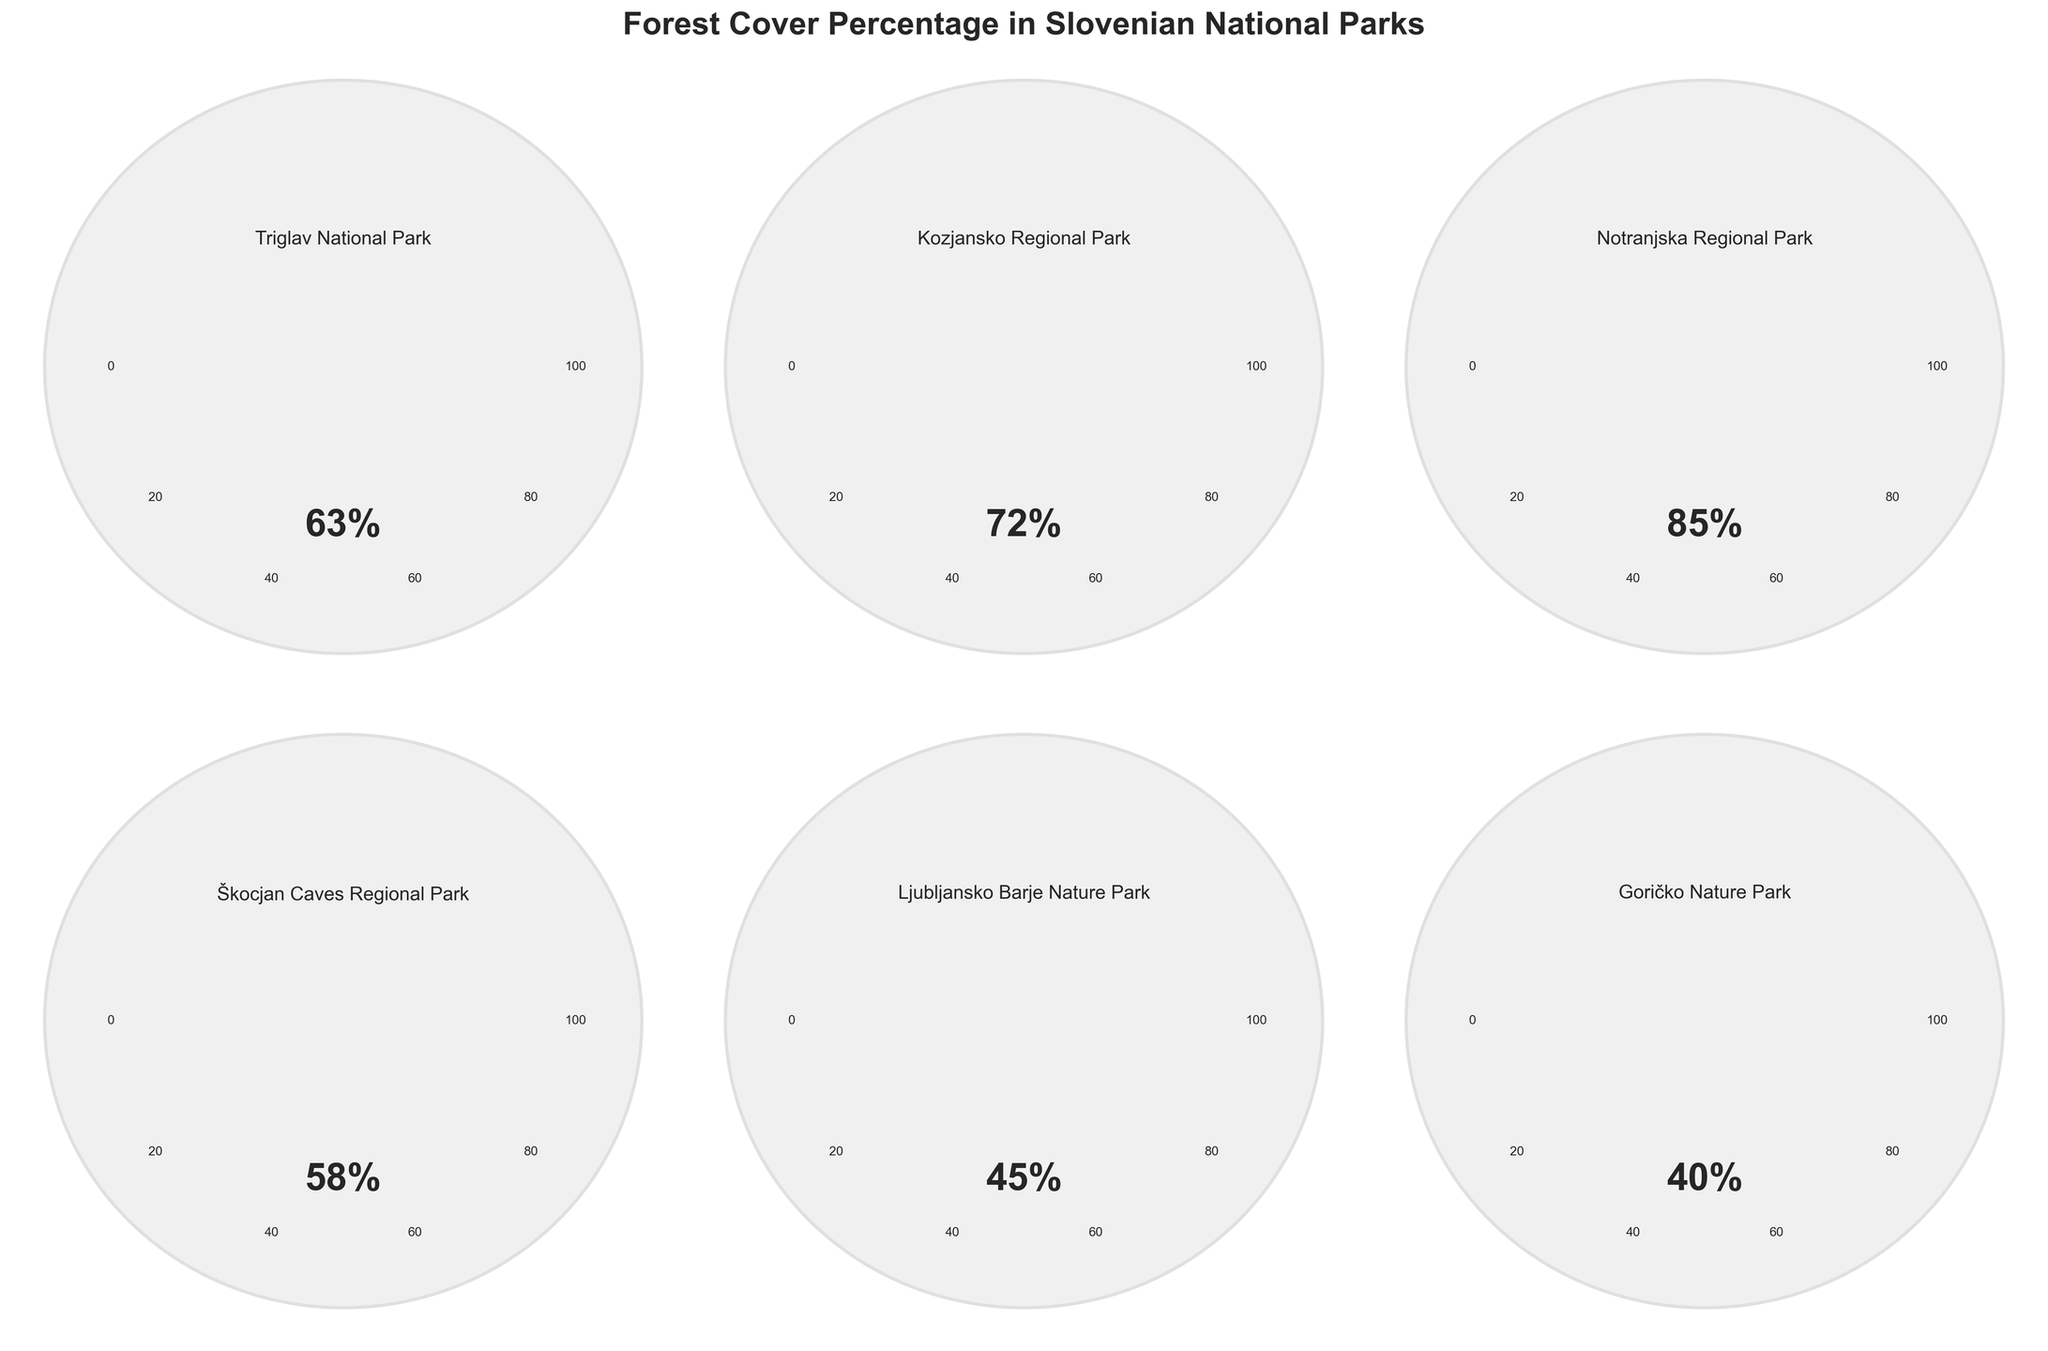What is the title of the figure? The title is typically at the top of the figure, and it gives an overview of what the chart represents. In this case, it reads "Forest Cover Percentage in Slovenian National Parks".
Answer: Forest Cover Percentage in Slovenian National Parks Which national park has the highest percentage of forest cover? By visually comparing the length and position of the gauge arcs, you can see that Notranjska Regional Park has the longest arc and therefore the highest value at 85%.
Answer: Notranjska Regional Park What is the forest cover percentage in Škocjan Caves Regional Park? Look directly at the gauge chart labeled Škocjan Caves Regional Park. The percentage is usually displayed in a large font within the gauge. Here it shows 58%.
Answer: 58% Which park has the lowest forest cover percentage? Look for the gauge with the shortest arc. The text within the gauge will show 40%, which corresponds to Goričko Nature Park.
Answer: Goričko Nature Park What is the average forest cover percentage across all the parks? To find the average, add all the percentages (63 + 72 + 85 + 58 + 45 + 40) = 363. Then divide by the number of parks, which is 6. 363/6 = 60.5
Answer: 60.5 How many parks have a forest cover percentage above 60%? Count the number of gauges with percentages greater than 60. Here, Triglav National Park (63), Kozjansko Regional Park (72), and Notranjska Regional Park (85) meet the criteria.
Answer: 3 What is the difference in forest cover percentage between Kozjansko Regional Park and Ljubljansko Barje Nature Park? Subtract the lower percentage (45) from the higher one (72). 72 - 45 = 27
Answer: 27 Which park has nearly half of its area covered by forests? Look for the park with a percentage close to 50%. Ljubljansko Barje Nature Park has 45%, which is nearly half.
Answer: Ljubljansko Barje Nature Park Compare the forest cover percentages in Triglav and Goričko parks. Which one has more? The gauge for Triglav National Park shows 63%, and the gauge for Goričko Nature Park shows 40%. Therefore, Triglav National Park has more forest cover.
Answer: Triglav National Park 